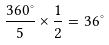<formula> <loc_0><loc_0><loc_500><loc_500>\frac { 3 6 0 ^ { \circ } } { 5 } \times \frac { 1 } { 2 } = 3 6 ^ { \circ }</formula> 